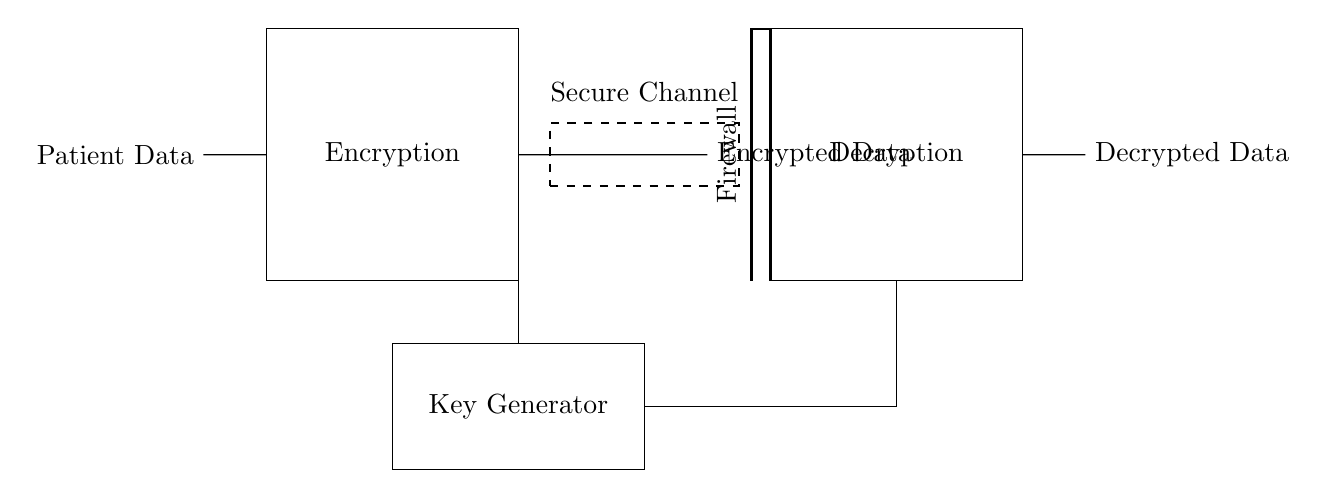What is the input of the circuit? The input of the circuit is labeled as "Patient Data," which is where the patient information enters the encryption block.
Answer: Patient Data What is the purpose of the firewall in this circuit? The purpose of the firewall is to provide a secure barrier that protects the data from unauthorized access, positioned between the encrypted data and the decryption block.
Answer: Security How many main blocks are present in this circuit? There are three main blocks in the circuit: the Encryption block, the Key Generator, and the Decryption block.
Answer: Three What connects the key generator to the encryption block? The key generator is connected to the encryption block through a direct line, indicating that a key is generated to perform the encryption operation.
Answer: A direct line What does the dashed line in the circuit represent? The dashed line represents a "Secure Channel," indicating that the data is transmitted securely between the encryption and decryption blocks, thereby enhancing security during the data transfer.
Answer: Secure Channel Why is the key generator positioned outside the encryption and decryption blocks? The key generator is positioned outside the encryption and decryption blocks to emphasize its role in generating the keys separately, which are then used for both the encryption and decryption processes, ensuring clarity in the circuit's function.
Answer: To generate keys separately What is the output of the decryption block? The output of the decryption block is labeled "Decrypted Data," representing the patient information that has been securely decrypted after being encrypted through the process.
Answer: Decrypted Data 